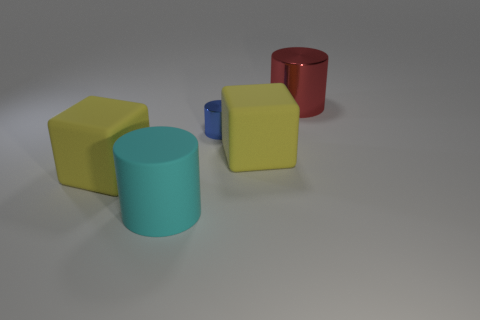How many red objects are small cylinders or big rubber cylinders?
Provide a succinct answer. 0. What number of big red cylinders are on the right side of the large red thing?
Provide a short and direct response. 0. There is a shiny cylinder that is to the left of the metallic object that is to the right of the yellow rubber block that is on the right side of the blue metal cylinder; what size is it?
Provide a succinct answer. Small. Is there a large matte cube behind the cube right of the metallic cylinder that is in front of the red metal thing?
Ensure brevity in your answer.  No. Is the number of small blue cylinders greater than the number of small yellow metallic balls?
Offer a very short reply. Yes. The shiny cylinder in front of the red metallic cylinder is what color?
Your answer should be very brief. Blue. Are there more big cyan cylinders behind the red metallic cylinder than big cyan rubber cylinders?
Your answer should be compact. No. Is the red cylinder made of the same material as the large cyan object?
Offer a very short reply. No. What number of other things are there of the same shape as the red object?
Your response must be concise. 2. Are there any other things that have the same material as the tiny cylinder?
Offer a very short reply. Yes. 